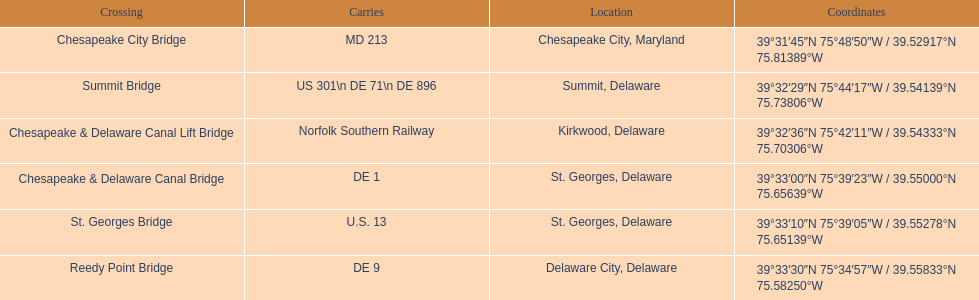Which bridge has their location in summit, delaware? Summit Bridge. 